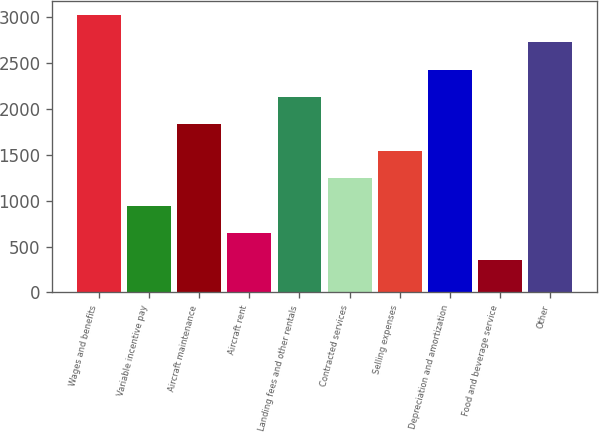Convert chart to OTSL. <chart><loc_0><loc_0><loc_500><loc_500><bar_chart><fcel>Wages and benefits<fcel>Variable incentive pay<fcel>Aircraft maintenance<fcel>Aircraft rent<fcel>Landing fees and other rentals<fcel>Contracted services<fcel>Selling expenses<fcel>Depreciation and amortization<fcel>Food and beverage service<fcel>Other<nl><fcel>3018<fcel>946<fcel>1834<fcel>650<fcel>2130<fcel>1242<fcel>1538<fcel>2426<fcel>354<fcel>2722<nl></chart> 